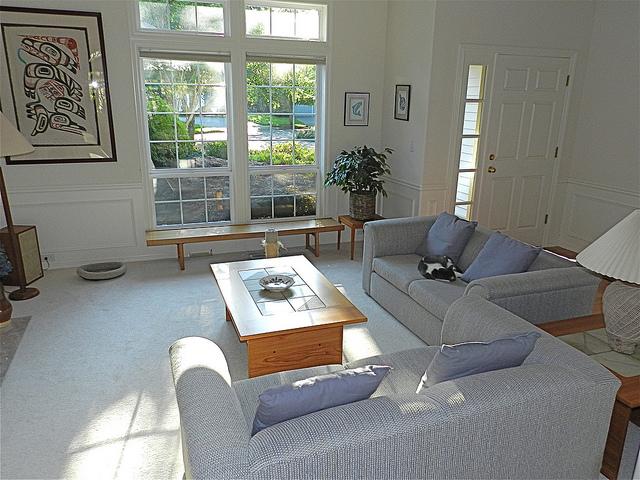Where is the tree at?
Concise answer only. Outside. About what time was this photo taken?
Short answer required. Afternoon. Is that the front door?
Give a very brief answer. Yes. What makes it possible to see light shine on the carpet?
Answer briefly. Windows. 